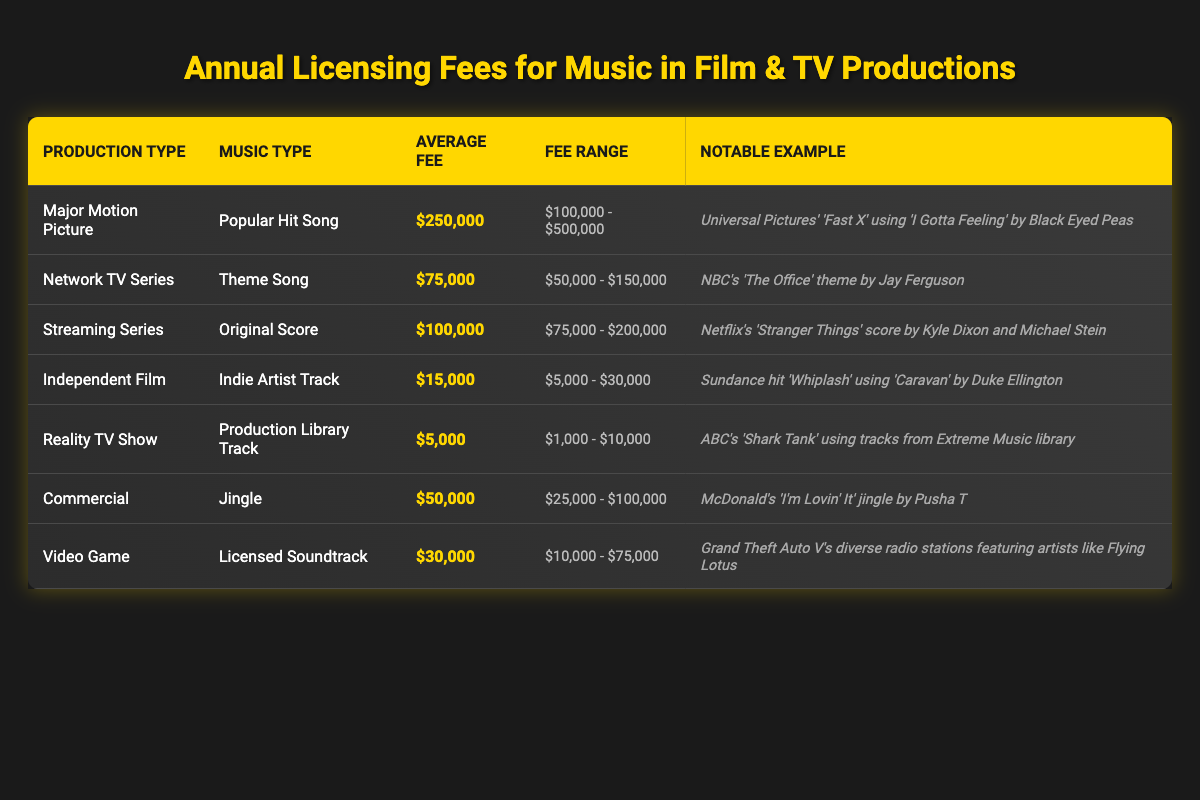What is the average licensing fee for music in a major motion picture? The row for "Major Motion Picture" indicates the average fee is $250,000.
Answer: $250,000 Which production has the lowest average licensing fee? The "Reality TV Show" has the lowest average fee of $5,000, as seen in the table.
Answer: $5,000 Is the average fee for a commercial higher than that of a network TV series? The average fee for a commercial is $50,000 and for a network TV series it's $75,000. Since $50,000 is not higher than $75,000, the answer is no.
Answer: No What is the fee range for an independent film? The fee range for an independent film is listed as $5,000 to $30,000.
Answer: $5,000 - $30,000 If we consider the average fees for all types of productions, what is the average licensing fee? The average fees for all productions are $250,000 (Major Motion Picture), $75,000 (Network TV Series), $100,000 (Streaming Series), $15,000 (Independent Film), $5,000 (Reality TV Show), $50,000 (Commercial), and $30,000 (Video Game). Adding these gives a total of $525,000. There are 7 production types, so the average fee is $525,000 / 7 = $75,000.
Answer: $75,000 Does using a popular hit song in a major motion picture cost more than an original score in a streaming series? The average fee for a popular hit song in a major motion picture is $250,000 while the average fee for an original score in a streaming series is $100,000. Since $250,000 is greater than $100,000, the answer is yes.
Answer: Yes What notable example is given for music used in a network TV series? The table states that the notable example for a network TV series is NBC's 'The Office' theme by Jay Ferguson.
Answer: NBC's 'The Office' theme by Jay Ferguson Which type of production uses the most expensive music on average? The "Major Motion Picture" category has the highest average fee at $250,000, based on the information in the table.
Answer: Major Motion Picture 